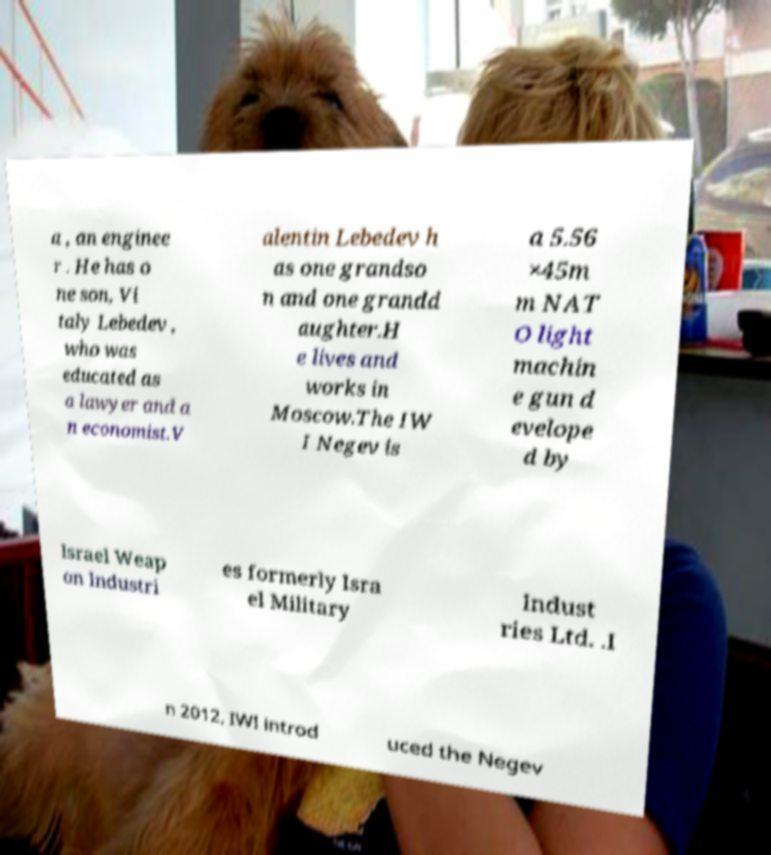Can you read and provide the text displayed in the image?This photo seems to have some interesting text. Can you extract and type it out for me? a , an enginee r . He has o ne son, Vi taly Lebedev , who was educated as a lawyer and a n economist.V alentin Lebedev h as one grandso n and one grandd aughter.H e lives and works in Moscow.The IW I Negev is a 5.56 ×45m m NAT O light machin e gun d evelope d by Israel Weap on Industri es formerly Isra el Military Indust ries Ltd. .I n 2012, IWI introd uced the Negev 